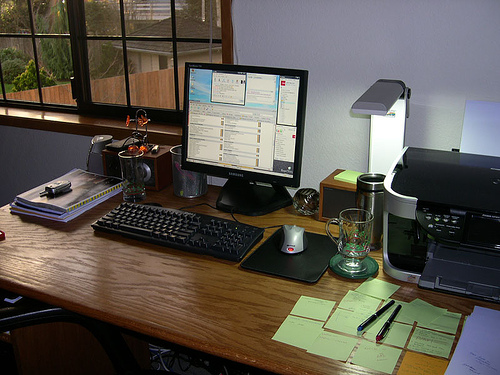<image>
Is the sticky note on the desk? Yes. Looking at the image, I can see the sticky note is positioned on top of the desk, with the desk providing support. 